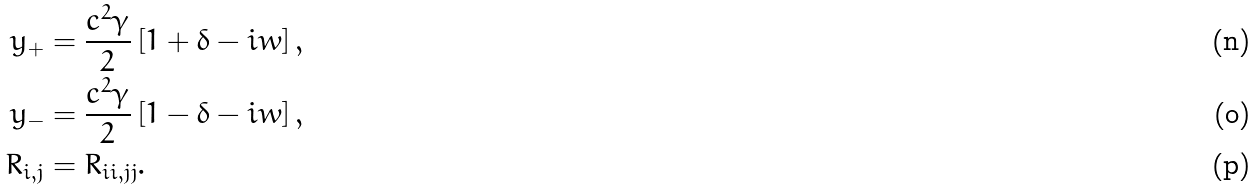<formula> <loc_0><loc_0><loc_500><loc_500>y _ { + } & = \frac { c ^ { 2 } \gamma } { 2 } \left [ 1 + \delta - i w \right ] , \\ y _ { - } & = \frac { c ^ { 2 } \gamma } { 2 } \left [ 1 - \delta - i w \right ] , \\ R _ { i , j } & = R _ { i i , j j } .</formula> 